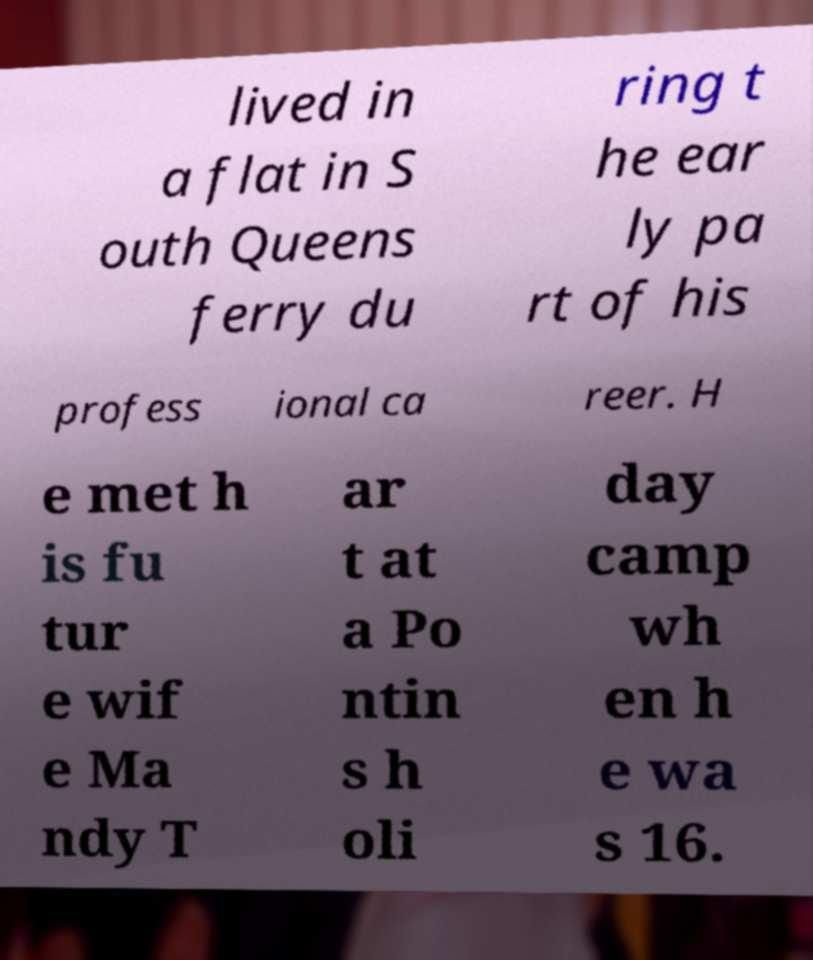Please read and relay the text visible in this image. What does it say? lived in a flat in S outh Queens ferry du ring t he ear ly pa rt of his profess ional ca reer. H e met h is fu tur e wif e Ma ndy T ar t at a Po ntin s h oli day camp wh en h e wa s 16. 